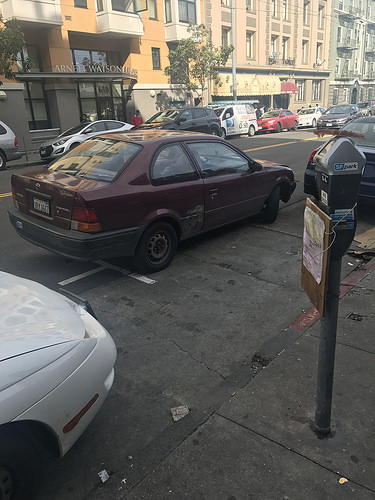<image>
Is the road to the right of the car? No. The road is not to the right of the car. The horizontal positioning shows a different relationship. 